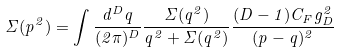Convert formula to latex. <formula><loc_0><loc_0><loc_500><loc_500>\Sigma ( p ^ { 2 } ) = \int \frac { d ^ { D } q } { ( 2 \pi ) ^ { D } } \frac { \Sigma ( q ^ { 2 } ) } { q ^ { 2 } + \Sigma ( q ^ { 2 } ) } \frac { ( D - 1 ) C _ { F } g _ { D } ^ { 2 } } { ( p - q ) ^ { 2 } }</formula> 